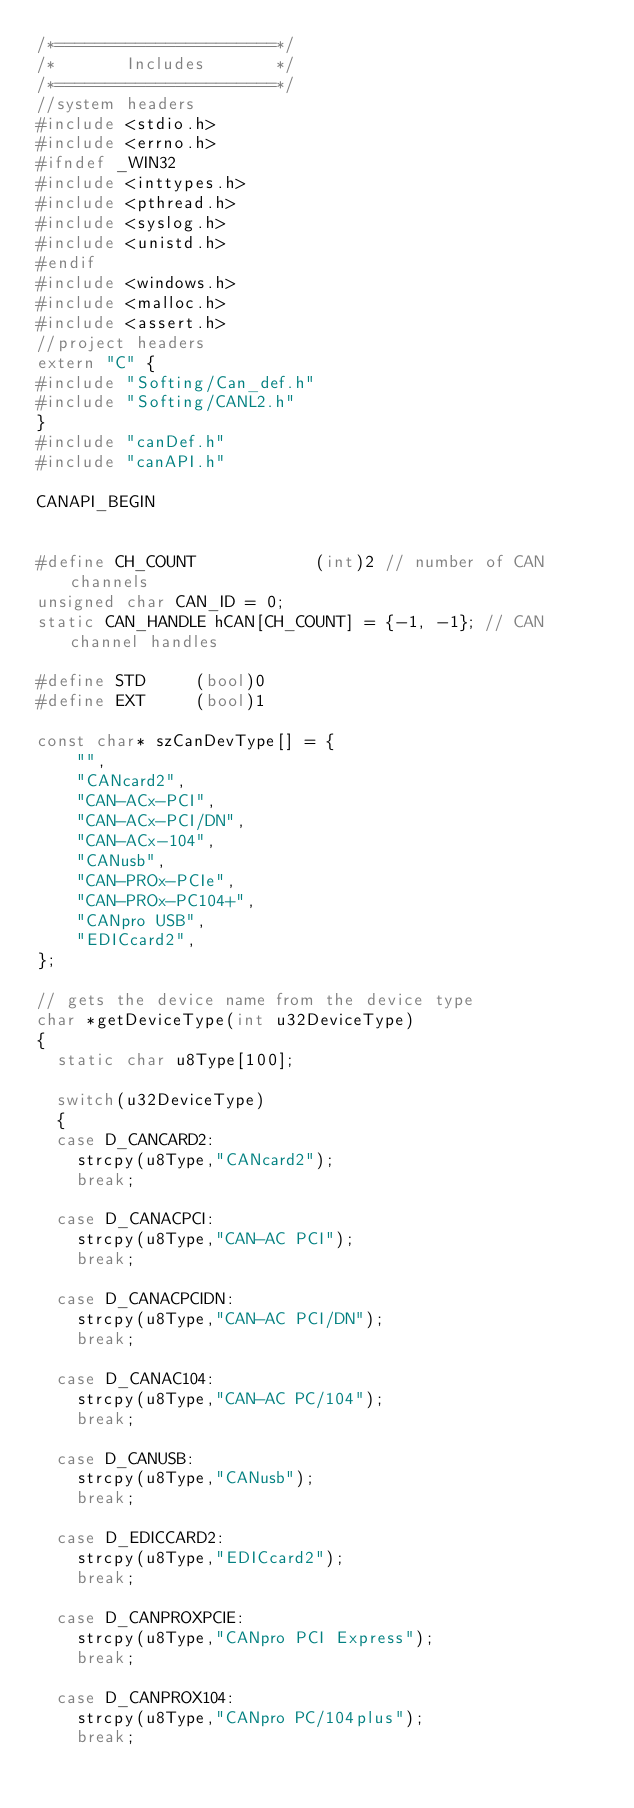<code> <loc_0><loc_0><loc_500><loc_500><_C++_>/*======================*/
/*       Includes       */
/*======================*/
//system headers
#include <stdio.h>
#include <errno.h>
#ifndef _WIN32
#include <inttypes.h>
#include <pthread.h>
#include <syslog.h>
#include <unistd.h>
#endif
#include <windows.h>
#include <malloc.h>
#include <assert.h>
//project headers
extern "C" {
#include "Softing/Can_def.h"
#include "Softing/CANL2.h"
}
#include "canDef.h"
#include "canAPI.h"

CANAPI_BEGIN


#define CH_COUNT			(int)2 // number of CAN channels
unsigned char CAN_ID = 0;
static CAN_HANDLE hCAN[CH_COUNT] = {-1, -1}; // CAN channel handles

#define	STD		(bool)0
#define	EXT		(bool)1

const char* szCanDevType[] = {
	"",
	"CANcard2",
	"CAN-ACx-PCI",
	"CAN-ACx-PCI/DN",
	"CAN-ACx-104",
	"CANusb",
	"CAN-PROx-PCIe", 
	"CAN-PROx-PC104+",
	"CANpro USB", 
	"EDICcard2",
};

// gets the device name from the device type
char *getDeviceType(int u32DeviceType)
{
  static char u8Type[100];

  switch(u32DeviceType)
  {
  case D_CANCARD2:
    strcpy(u8Type,"CANcard2");
    break;

  case D_CANACPCI:
    strcpy(u8Type,"CAN-AC PCI");
    break;

  case D_CANACPCIDN:
    strcpy(u8Type,"CAN-AC PCI/DN");
    break;

  case D_CANAC104:
    strcpy(u8Type,"CAN-AC PC/104");
    break;

  case D_CANUSB:
    strcpy(u8Type,"CANusb");
    break;

  case D_EDICCARD2:
    strcpy(u8Type,"EDICcard2");
    break;

  case D_CANPROXPCIE:
    strcpy(u8Type,"CANpro PCI Express");
    break;

  case D_CANPROX104:
    strcpy(u8Type,"CANpro PC/104plus");
    break;
</code> 